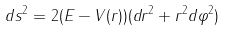Convert formula to latex. <formula><loc_0><loc_0><loc_500><loc_500>d s ^ { 2 } = 2 ( E - V ( r ) ) ( d r ^ { 2 } + r ^ { 2 } d \varphi ^ { 2 } )</formula> 